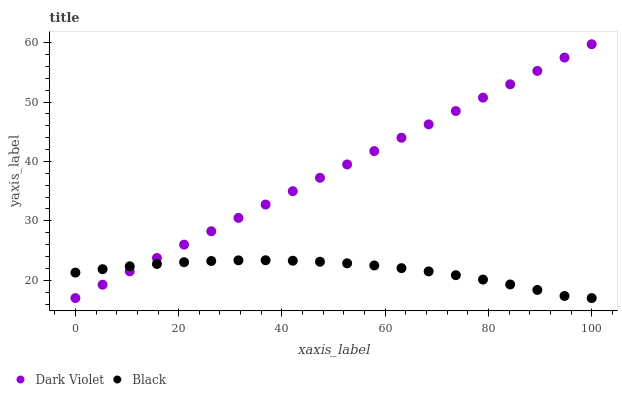Does Black have the minimum area under the curve?
Answer yes or no. Yes. Does Dark Violet have the maximum area under the curve?
Answer yes or no. Yes. Does Dark Violet have the minimum area under the curve?
Answer yes or no. No. Is Dark Violet the smoothest?
Answer yes or no. Yes. Is Black the roughest?
Answer yes or no. Yes. Is Dark Violet the roughest?
Answer yes or no. No. Does Black have the lowest value?
Answer yes or no. Yes. Does Dark Violet have the highest value?
Answer yes or no. Yes. Does Black intersect Dark Violet?
Answer yes or no. Yes. Is Black less than Dark Violet?
Answer yes or no. No. Is Black greater than Dark Violet?
Answer yes or no. No. 